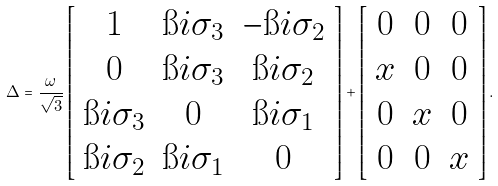<formula> <loc_0><loc_0><loc_500><loc_500>\Delta = \frac { \omega } { \sqrt { 3 } } \left [ \begin{array} { c c c } { 1 } & \i i \sigma _ { 3 } & - \i i \sigma _ { 2 } \\ 0 & \i i \sigma _ { 3 } & \i i \sigma _ { 2 } \\ \i i \sigma _ { 3 } & 0 & \i i \sigma _ { 1 } \\ \i i \sigma _ { 2 } & \i i \sigma _ { 1 } & 0 \end{array} \right ] + \left [ \begin{array} { c c c } 0 & 0 & 0 \\ x & 0 & 0 \\ 0 & x & 0 \\ 0 & 0 & x \end{array} \right ] .</formula> 